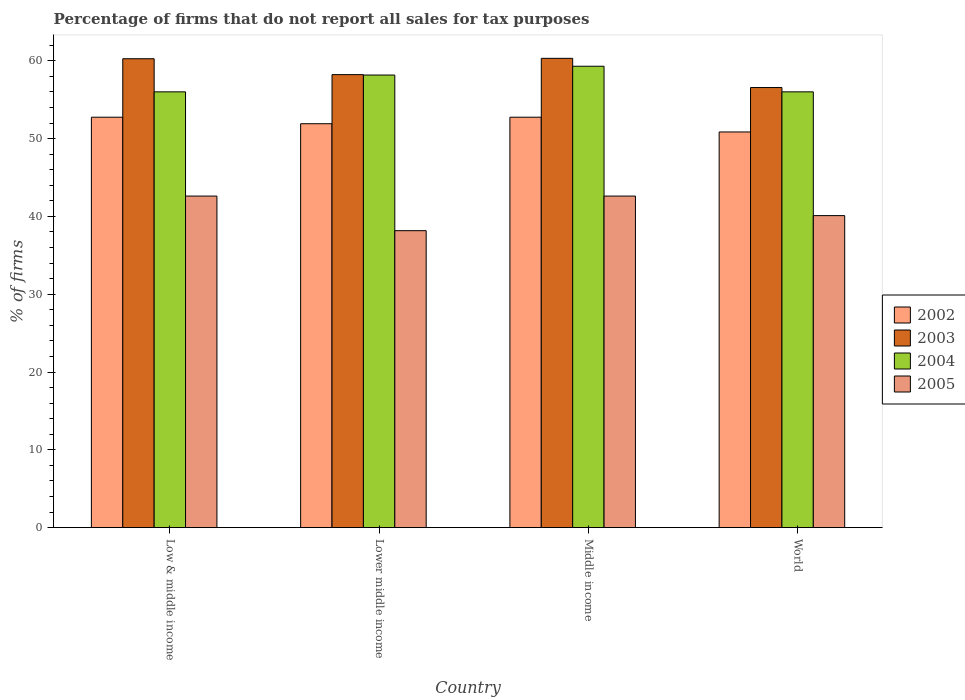How many groups of bars are there?
Offer a terse response. 4. Are the number of bars per tick equal to the number of legend labels?
Your answer should be compact. Yes. Are the number of bars on each tick of the X-axis equal?
Your answer should be very brief. Yes. How many bars are there on the 4th tick from the right?
Keep it short and to the point. 4. In how many cases, is the number of bars for a given country not equal to the number of legend labels?
Keep it short and to the point. 0. What is the percentage of firms that do not report all sales for tax purposes in 2005 in Lower middle income?
Provide a succinct answer. 38.16. Across all countries, what is the maximum percentage of firms that do not report all sales for tax purposes in 2002?
Ensure brevity in your answer.  52.75. Across all countries, what is the minimum percentage of firms that do not report all sales for tax purposes in 2003?
Your response must be concise. 56.56. In which country was the percentage of firms that do not report all sales for tax purposes in 2004 minimum?
Make the answer very short. Low & middle income. What is the total percentage of firms that do not report all sales for tax purposes in 2004 in the graph?
Provide a succinct answer. 229.47. What is the difference between the percentage of firms that do not report all sales for tax purposes in 2003 in Low & middle income and that in World?
Your answer should be very brief. 3.7. What is the difference between the percentage of firms that do not report all sales for tax purposes in 2002 in Lower middle income and the percentage of firms that do not report all sales for tax purposes in 2004 in Middle income?
Offer a terse response. -7.39. What is the average percentage of firms that do not report all sales for tax purposes in 2005 per country?
Offer a very short reply. 40.87. What is the difference between the percentage of firms that do not report all sales for tax purposes of/in 2002 and percentage of firms that do not report all sales for tax purposes of/in 2005 in Middle income?
Provide a succinct answer. 10.13. Is the difference between the percentage of firms that do not report all sales for tax purposes in 2002 in Lower middle income and World greater than the difference between the percentage of firms that do not report all sales for tax purposes in 2005 in Lower middle income and World?
Your response must be concise. Yes. What is the difference between the highest and the second highest percentage of firms that do not report all sales for tax purposes in 2003?
Your answer should be very brief. -2.09. What is the difference between the highest and the lowest percentage of firms that do not report all sales for tax purposes in 2004?
Offer a terse response. 3.29. In how many countries, is the percentage of firms that do not report all sales for tax purposes in 2005 greater than the average percentage of firms that do not report all sales for tax purposes in 2005 taken over all countries?
Keep it short and to the point. 2. Is it the case that in every country, the sum of the percentage of firms that do not report all sales for tax purposes in 2005 and percentage of firms that do not report all sales for tax purposes in 2004 is greater than the sum of percentage of firms that do not report all sales for tax purposes in 2003 and percentage of firms that do not report all sales for tax purposes in 2002?
Offer a terse response. Yes. How many bars are there?
Keep it short and to the point. 16. How many countries are there in the graph?
Your answer should be compact. 4. What is the difference between two consecutive major ticks on the Y-axis?
Offer a terse response. 10. Are the values on the major ticks of Y-axis written in scientific E-notation?
Your answer should be very brief. No. Does the graph contain grids?
Give a very brief answer. No. How are the legend labels stacked?
Your answer should be very brief. Vertical. What is the title of the graph?
Offer a very short reply. Percentage of firms that do not report all sales for tax purposes. Does "1990" appear as one of the legend labels in the graph?
Your response must be concise. No. What is the label or title of the Y-axis?
Provide a succinct answer. % of firms. What is the % of firms in 2002 in Low & middle income?
Keep it short and to the point. 52.75. What is the % of firms in 2003 in Low & middle income?
Offer a terse response. 60.26. What is the % of firms of 2004 in Low & middle income?
Your response must be concise. 56.01. What is the % of firms of 2005 in Low & middle income?
Offer a terse response. 42.61. What is the % of firms in 2002 in Lower middle income?
Your answer should be compact. 51.91. What is the % of firms in 2003 in Lower middle income?
Your answer should be very brief. 58.22. What is the % of firms in 2004 in Lower middle income?
Provide a short and direct response. 58.16. What is the % of firms of 2005 in Lower middle income?
Provide a short and direct response. 38.16. What is the % of firms in 2002 in Middle income?
Give a very brief answer. 52.75. What is the % of firms in 2003 in Middle income?
Provide a short and direct response. 60.31. What is the % of firms in 2004 in Middle income?
Keep it short and to the point. 59.3. What is the % of firms of 2005 in Middle income?
Offer a very short reply. 42.61. What is the % of firms in 2002 in World?
Provide a succinct answer. 50.85. What is the % of firms of 2003 in World?
Make the answer very short. 56.56. What is the % of firms of 2004 in World?
Make the answer very short. 56.01. What is the % of firms of 2005 in World?
Keep it short and to the point. 40.1. Across all countries, what is the maximum % of firms in 2002?
Provide a succinct answer. 52.75. Across all countries, what is the maximum % of firms in 2003?
Offer a very short reply. 60.31. Across all countries, what is the maximum % of firms in 2004?
Offer a very short reply. 59.3. Across all countries, what is the maximum % of firms in 2005?
Offer a very short reply. 42.61. Across all countries, what is the minimum % of firms in 2002?
Your response must be concise. 50.85. Across all countries, what is the minimum % of firms of 2003?
Your answer should be compact. 56.56. Across all countries, what is the minimum % of firms in 2004?
Your answer should be very brief. 56.01. Across all countries, what is the minimum % of firms in 2005?
Your answer should be very brief. 38.16. What is the total % of firms in 2002 in the graph?
Provide a short and direct response. 208.25. What is the total % of firms of 2003 in the graph?
Make the answer very short. 235.35. What is the total % of firms in 2004 in the graph?
Offer a very short reply. 229.47. What is the total % of firms of 2005 in the graph?
Your response must be concise. 163.48. What is the difference between the % of firms of 2002 in Low & middle income and that in Lower middle income?
Provide a succinct answer. 0.84. What is the difference between the % of firms of 2003 in Low & middle income and that in Lower middle income?
Provide a succinct answer. 2.04. What is the difference between the % of firms of 2004 in Low & middle income and that in Lower middle income?
Offer a terse response. -2.16. What is the difference between the % of firms of 2005 in Low & middle income and that in Lower middle income?
Make the answer very short. 4.45. What is the difference between the % of firms of 2002 in Low & middle income and that in Middle income?
Offer a very short reply. 0. What is the difference between the % of firms in 2003 in Low & middle income and that in Middle income?
Provide a succinct answer. -0.05. What is the difference between the % of firms in 2004 in Low & middle income and that in Middle income?
Provide a succinct answer. -3.29. What is the difference between the % of firms of 2002 in Low & middle income and that in World?
Your response must be concise. 1.89. What is the difference between the % of firms of 2005 in Low & middle income and that in World?
Your response must be concise. 2.51. What is the difference between the % of firms in 2002 in Lower middle income and that in Middle income?
Your answer should be very brief. -0.84. What is the difference between the % of firms of 2003 in Lower middle income and that in Middle income?
Keep it short and to the point. -2.09. What is the difference between the % of firms of 2004 in Lower middle income and that in Middle income?
Your answer should be compact. -1.13. What is the difference between the % of firms in 2005 in Lower middle income and that in Middle income?
Offer a terse response. -4.45. What is the difference between the % of firms of 2002 in Lower middle income and that in World?
Your response must be concise. 1.06. What is the difference between the % of firms of 2003 in Lower middle income and that in World?
Offer a terse response. 1.66. What is the difference between the % of firms in 2004 in Lower middle income and that in World?
Make the answer very short. 2.16. What is the difference between the % of firms in 2005 in Lower middle income and that in World?
Your response must be concise. -1.94. What is the difference between the % of firms of 2002 in Middle income and that in World?
Offer a very short reply. 1.89. What is the difference between the % of firms in 2003 in Middle income and that in World?
Offer a terse response. 3.75. What is the difference between the % of firms of 2004 in Middle income and that in World?
Keep it short and to the point. 3.29. What is the difference between the % of firms of 2005 in Middle income and that in World?
Provide a short and direct response. 2.51. What is the difference between the % of firms of 2002 in Low & middle income and the % of firms of 2003 in Lower middle income?
Your answer should be very brief. -5.47. What is the difference between the % of firms of 2002 in Low & middle income and the % of firms of 2004 in Lower middle income?
Offer a very short reply. -5.42. What is the difference between the % of firms of 2002 in Low & middle income and the % of firms of 2005 in Lower middle income?
Your answer should be very brief. 14.58. What is the difference between the % of firms of 2003 in Low & middle income and the % of firms of 2004 in Lower middle income?
Your response must be concise. 2.1. What is the difference between the % of firms in 2003 in Low & middle income and the % of firms in 2005 in Lower middle income?
Ensure brevity in your answer.  22.1. What is the difference between the % of firms in 2004 in Low & middle income and the % of firms in 2005 in Lower middle income?
Offer a terse response. 17.84. What is the difference between the % of firms in 2002 in Low & middle income and the % of firms in 2003 in Middle income?
Make the answer very short. -7.57. What is the difference between the % of firms in 2002 in Low & middle income and the % of firms in 2004 in Middle income?
Give a very brief answer. -6.55. What is the difference between the % of firms of 2002 in Low & middle income and the % of firms of 2005 in Middle income?
Your answer should be compact. 10.13. What is the difference between the % of firms of 2003 in Low & middle income and the % of firms of 2004 in Middle income?
Your response must be concise. 0.96. What is the difference between the % of firms in 2003 in Low & middle income and the % of firms in 2005 in Middle income?
Ensure brevity in your answer.  17.65. What is the difference between the % of firms of 2004 in Low & middle income and the % of firms of 2005 in Middle income?
Make the answer very short. 13.39. What is the difference between the % of firms in 2002 in Low & middle income and the % of firms in 2003 in World?
Your response must be concise. -3.81. What is the difference between the % of firms in 2002 in Low & middle income and the % of firms in 2004 in World?
Your answer should be compact. -3.26. What is the difference between the % of firms in 2002 in Low & middle income and the % of firms in 2005 in World?
Ensure brevity in your answer.  12.65. What is the difference between the % of firms in 2003 in Low & middle income and the % of firms in 2004 in World?
Offer a terse response. 4.25. What is the difference between the % of firms of 2003 in Low & middle income and the % of firms of 2005 in World?
Provide a short and direct response. 20.16. What is the difference between the % of firms in 2004 in Low & middle income and the % of firms in 2005 in World?
Ensure brevity in your answer.  15.91. What is the difference between the % of firms in 2002 in Lower middle income and the % of firms in 2003 in Middle income?
Your answer should be very brief. -8.4. What is the difference between the % of firms of 2002 in Lower middle income and the % of firms of 2004 in Middle income?
Your response must be concise. -7.39. What is the difference between the % of firms in 2002 in Lower middle income and the % of firms in 2005 in Middle income?
Keep it short and to the point. 9.3. What is the difference between the % of firms in 2003 in Lower middle income and the % of firms in 2004 in Middle income?
Keep it short and to the point. -1.08. What is the difference between the % of firms of 2003 in Lower middle income and the % of firms of 2005 in Middle income?
Provide a succinct answer. 15.61. What is the difference between the % of firms in 2004 in Lower middle income and the % of firms in 2005 in Middle income?
Keep it short and to the point. 15.55. What is the difference between the % of firms in 2002 in Lower middle income and the % of firms in 2003 in World?
Offer a terse response. -4.65. What is the difference between the % of firms in 2002 in Lower middle income and the % of firms in 2004 in World?
Ensure brevity in your answer.  -4.1. What is the difference between the % of firms in 2002 in Lower middle income and the % of firms in 2005 in World?
Ensure brevity in your answer.  11.81. What is the difference between the % of firms of 2003 in Lower middle income and the % of firms of 2004 in World?
Ensure brevity in your answer.  2.21. What is the difference between the % of firms of 2003 in Lower middle income and the % of firms of 2005 in World?
Make the answer very short. 18.12. What is the difference between the % of firms in 2004 in Lower middle income and the % of firms in 2005 in World?
Provide a succinct answer. 18.07. What is the difference between the % of firms in 2002 in Middle income and the % of firms in 2003 in World?
Your response must be concise. -3.81. What is the difference between the % of firms of 2002 in Middle income and the % of firms of 2004 in World?
Offer a terse response. -3.26. What is the difference between the % of firms in 2002 in Middle income and the % of firms in 2005 in World?
Your answer should be compact. 12.65. What is the difference between the % of firms in 2003 in Middle income and the % of firms in 2004 in World?
Give a very brief answer. 4.31. What is the difference between the % of firms of 2003 in Middle income and the % of firms of 2005 in World?
Ensure brevity in your answer.  20.21. What is the difference between the % of firms of 2004 in Middle income and the % of firms of 2005 in World?
Make the answer very short. 19.2. What is the average % of firms in 2002 per country?
Make the answer very short. 52.06. What is the average % of firms of 2003 per country?
Your answer should be very brief. 58.84. What is the average % of firms of 2004 per country?
Your answer should be very brief. 57.37. What is the average % of firms of 2005 per country?
Give a very brief answer. 40.87. What is the difference between the % of firms of 2002 and % of firms of 2003 in Low & middle income?
Your response must be concise. -7.51. What is the difference between the % of firms of 2002 and % of firms of 2004 in Low & middle income?
Your answer should be compact. -3.26. What is the difference between the % of firms of 2002 and % of firms of 2005 in Low & middle income?
Your answer should be very brief. 10.13. What is the difference between the % of firms in 2003 and % of firms in 2004 in Low & middle income?
Keep it short and to the point. 4.25. What is the difference between the % of firms of 2003 and % of firms of 2005 in Low & middle income?
Offer a terse response. 17.65. What is the difference between the % of firms in 2004 and % of firms in 2005 in Low & middle income?
Make the answer very short. 13.39. What is the difference between the % of firms in 2002 and % of firms in 2003 in Lower middle income?
Keep it short and to the point. -6.31. What is the difference between the % of firms of 2002 and % of firms of 2004 in Lower middle income?
Make the answer very short. -6.26. What is the difference between the % of firms in 2002 and % of firms in 2005 in Lower middle income?
Your response must be concise. 13.75. What is the difference between the % of firms in 2003 and % of firms in 2004 in Lower middle income?
Your response must be concise. 0.05. What is the difference between the % of firms of 2003 and % of firms of 2005 in Lower middle income?
Provide a short and direct response. 20.06. What is the difference between the % of firms in 2004 and % of firms in 2005 in Lower middle income?
Ensure brevity in your answer.  20. What is the difference between the % of firms of 2002 and % of firms of 2003 in Middle income?
Make the answer very short. -7.57. What is the difference between the % of firms in 2002 and % of firms in 2004 in Middle income?
Your response must be concise. -6.55. What is the difference between the % of firms in 2002 and % of firms in 2005 in Middle income?
Your response must be concise. 10.13. What is the difference between the % of firms of 2003 and % of firms of 2004 in Middle income?
Your answer should be very brief. 1.02. What is the difference between the % of firms of 2003 and % of firms of 2005 in Middle income?
Your answer should be very brief. 17.7. What is the difference between the % of firms in 2004 and % of firms in 2005 in Middle income?
Offer a terse response. 16.69. What is the difference between the % of firms in 2002 and % of firms in 2003 in World?
Your response must be concise. -5.71. What is the difference between the % of firms in 2002 and % of firms in 2004 in World?
Your answer should be compact. -5.15. What is the difference between the % of firms of 2002 and % of firms of 2005 in World?
Your response must be concise. 10.75. What is the difference between the % of firms in 2003 and % of firms in 2004 in World?
Your response must be concise. 0.56. What is the difference between the % of firms in 2003 and % of firms in 2005 in World?
Keep it short and to the point. 16.46. What is the difference between the % of firms of 2004 and % of firms of 2005 in World?
Provide a short and direct response. 15.91. What is the ratio of the % of firms of 2002 in Low & middle income to that in Lower middle income?
Your response must be concise. 1.02. What is the ratio of the % of firms in 2003 in Low & middle income to that in Lower middle income?
Ensure brevity in your answer.  1.04. What is the ratio of the % of firms of 2004 in Low & middle income to that in Lower middle income?
Your answer should be compact. 0.96. What is the ratio of the % of firms of 2005 in Low & middle income to that in Lower middle income?
Provide a succinct answer. 1.12. What is the ratio of the % of firms of 2002 in Low & middle income to that in Middle income?
Your answer should be compact. 1. What is the ratio of the % of firms in 2004 in Low & middle income to that in Middle income?
Offer a very short reply. 0.94. What is the ratio of the % of firms in 2002 in Low & middle income to that in World?
Your response must be concise. 1.04. What is the ratio of the % of firms of 2003 in Low & middle income to that in World?
Offer a terse response. 1.07. What is the ratio of the % of firms of 2004 in Low & middle income to that in World?
Ensure brevity in your answer.  1. What is the ratio of the % of firms of 2005 in Low & middle income to that in World?
Offer a very short reply. 1.06. What is the ratio of the % of firms of 2002 in Lower middle income to that in Middle income?
Offer a very short reply. 0.98. What is the ratio of the % of firms in 2003 in Lower middle income to that in Middle income?
Your answer should be compact. 0.97. What is the ratio of the % of firms in 2004 in Lower middle income to that in Middle income?
Your answer should be very brief. 0.98. What is the ratio of the % of firms of 2005 in Lower middle income to that in Middle income?
Provide a succinct answer. 0.9. What is the ratio of the % of firms in 2002 in Lower middle income to that in World?
Keep it short and to the point. 1.02. What is the ratio of the % of firms of 2003 in Lower middle income to that in World?
Your answer should be very brief. 1.03. What is the ratio of the % of firms of 2004 in Lower middle income to that in World?
Ensure brevity in your answer.  1.04. What is the ratio of the % of firms of 2005 in Lower middle income to that in World?
Your response must be concise. 0.95. What is the ratio of the % of firms of 2002 in Middle income to that in World?
Your response must be concise. 1.04. What is the ratio of the % of firms in 2003 in Middle income to that in World?
Give a very brief answer. 1.07. What is the ratio of the % of firms of 2004 in Middle income to that in World?
Provide a short and direct response. 1.06. What is the ratio of the % of firms of 2005 in Middle income to that in World?
Your answer should be compact. 1.06. What is the difference between the highest and the second highest % of firms in 2002?
Offer a terse response. 0. What is the difference between the highest and the second highest % of firms in 2003?
Ensure brevity in your answer.  0.05. What is the difference between the highest and the second highest % of firms of 2004?
Make the answer very short. 1.13. What is the difference between the highest and the second highest % of firms in 2005?
Offer a terse response. 0. What is the difference between the highest and the lowest % of firms of 2002?
Offer a terse response. 1.89. What is the difference between the highest and the lowest % of firms of 2003?
Your answer should be compact. 3.75. What is the difference between the highest and the lowest % of firms of 2004?
Ensure brevity in your answer.  3.29. What is the difference between the highest and the lowest % of firms of 2005?
Keep it short and to the point. 4.45. 